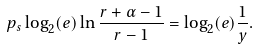Convert formula to latex. <formula><loc_0><loc_0><loc_500><loc_500>p _ { s } \log _ { 2 } ( e ) \ln \frac { r + \alpha - 1 } { r - 1 } = \log _ { 2 } ( e ) \frac { 1 } { y } .</formula> 